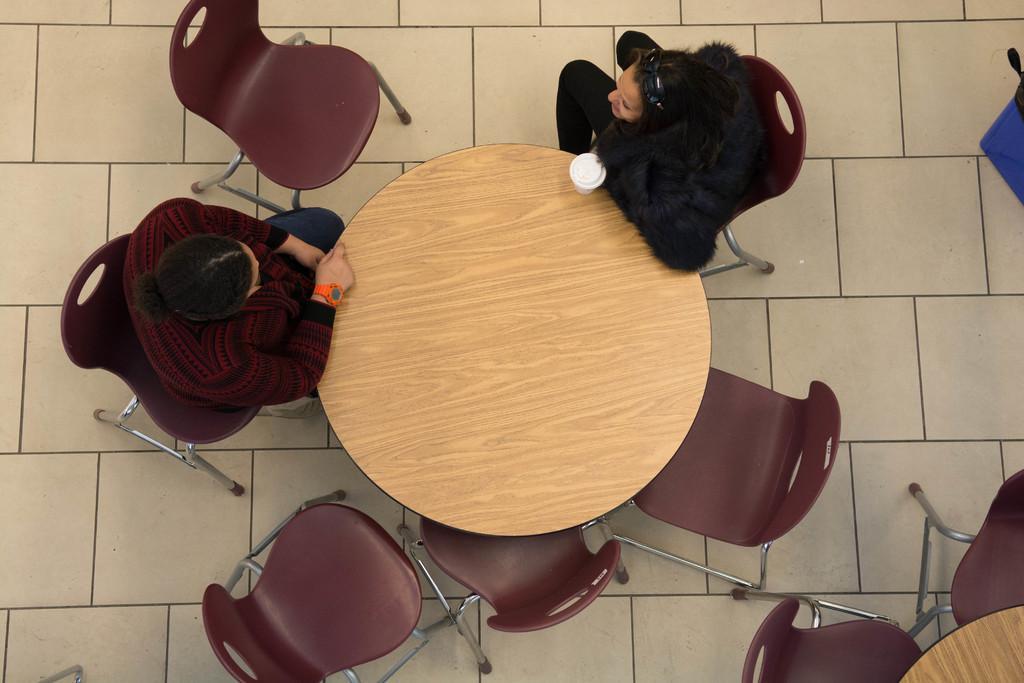Can you describe this image briefly? As we can see in the image there are chairs and two people sitting on chairs. In front of them there is a table. On table there is a glass. 